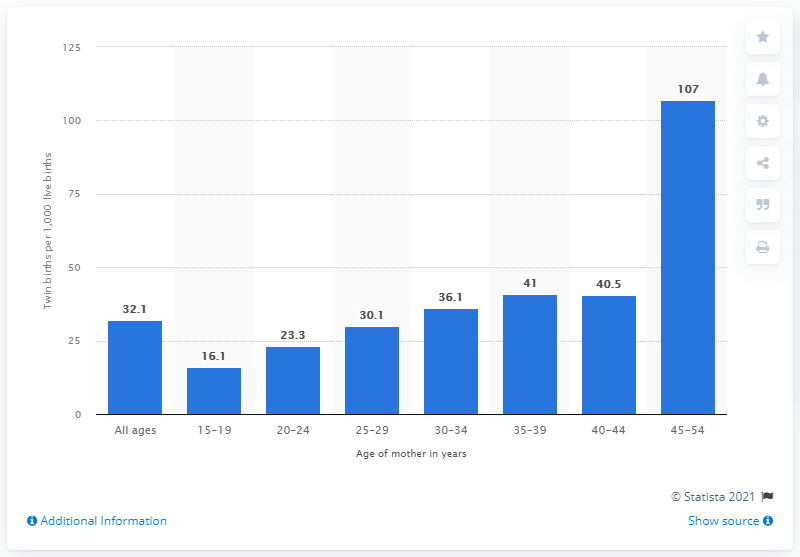Outline some significant characteristics in this image. In 2018, approximately 16.1% of live births were twin births among mothers between the ages of 15 and 19. 